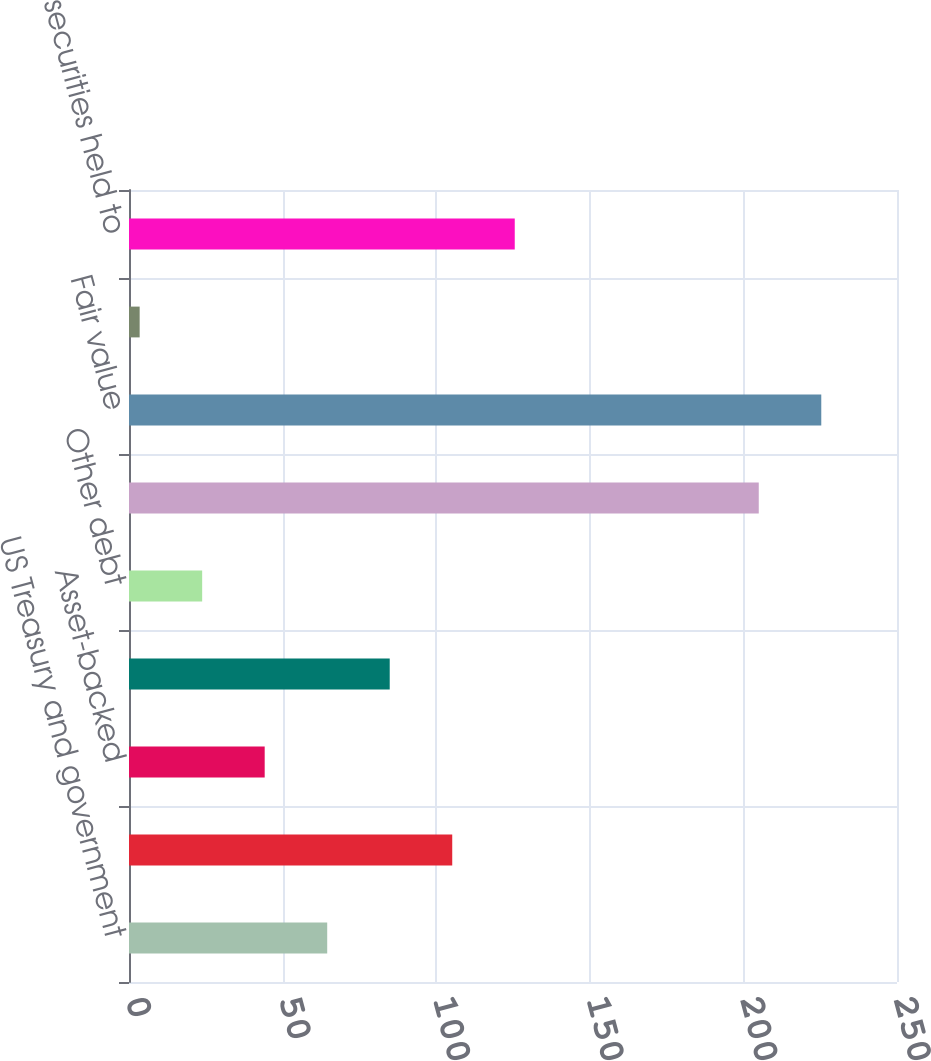Convert chart. <chart><loc_0><loc_0><loc_500><loc_500><bar_chart><fcel>US Treasury and government<fcel>Agency<fcel>Asset-backed<fcel>State and municipal<fcel>Other debt<fcel>Total debt securities<fcel>Fair value<fcel>Weighted-average yield GAAP<fcel>Total debt securities held to<nl><fcel>64.52<fcel>105.22<fcel>44.17<fcel>84.87<fcel>23.82<fcel>205<fcel>225.35<fcel>3.47<fcel>125.57<nl></chart> 